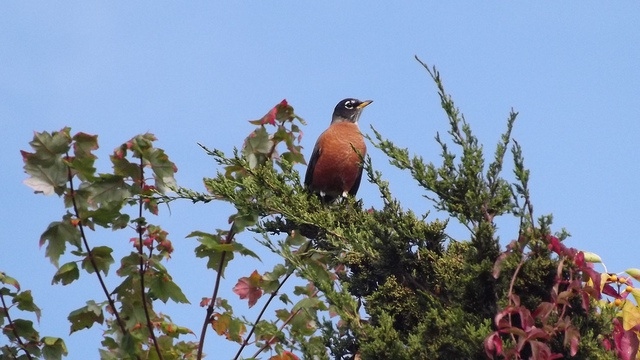Describe the objects in this image and their specific colors. I can see a bird in lightblue, black, maroon, salmon, and brown tones in this image. 